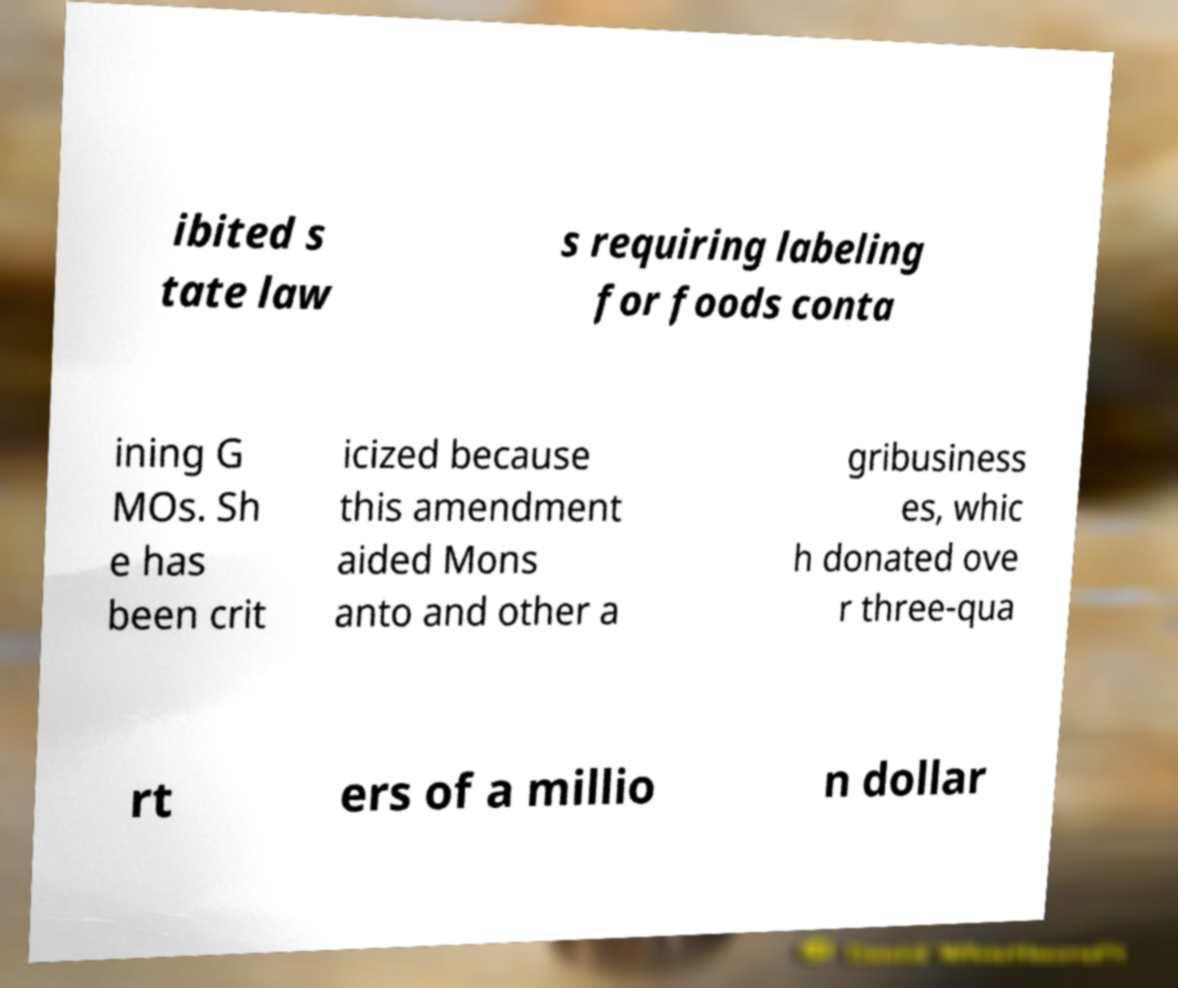Please read and relay the text visible in this image. What does it say? ibited s tate law s requiring labeling for foods conta ining G MOs. Sh e has been crit icized because this amendment aided Mons anto and other a gribusiness es, whic h donated ove r three-qua rt ers of a millio n dollar 